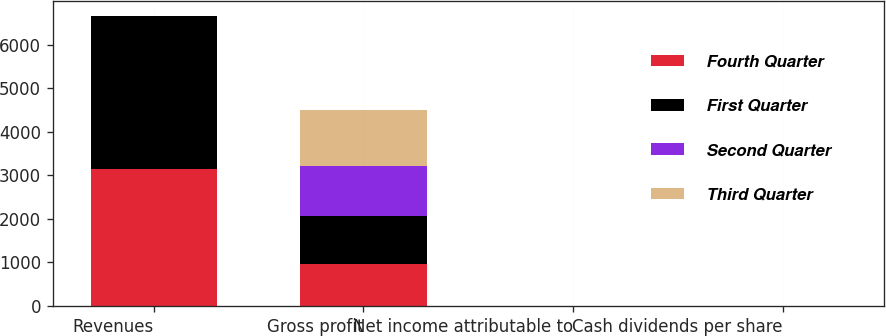Convert chart to OTSL. <chart><loc_0><loc_0><loc_500><loc_500><stacked_bar_chart><ecel><fcel>Revenues<fcel>Gross profit<fcel>Net income attributable to<fcel>Cash dividends per share<nl><fcel>Fourth Quarter<fcel>3146<fcel>975<fcel>0.96<fcel>0.11<nl><fcel>First Quarter<fcel>3513<fcel>1083<fcel>1.13<fcel>0.11<nl><fcel>Second Quarter<fcel>1.355<fcel>1164<fcel>1.25<fcel>0.11<nl><fcel>Third Quarter<fcel>1.355<fcel>1275<fcel>1.35<fcel>0.12<nl></chart> 